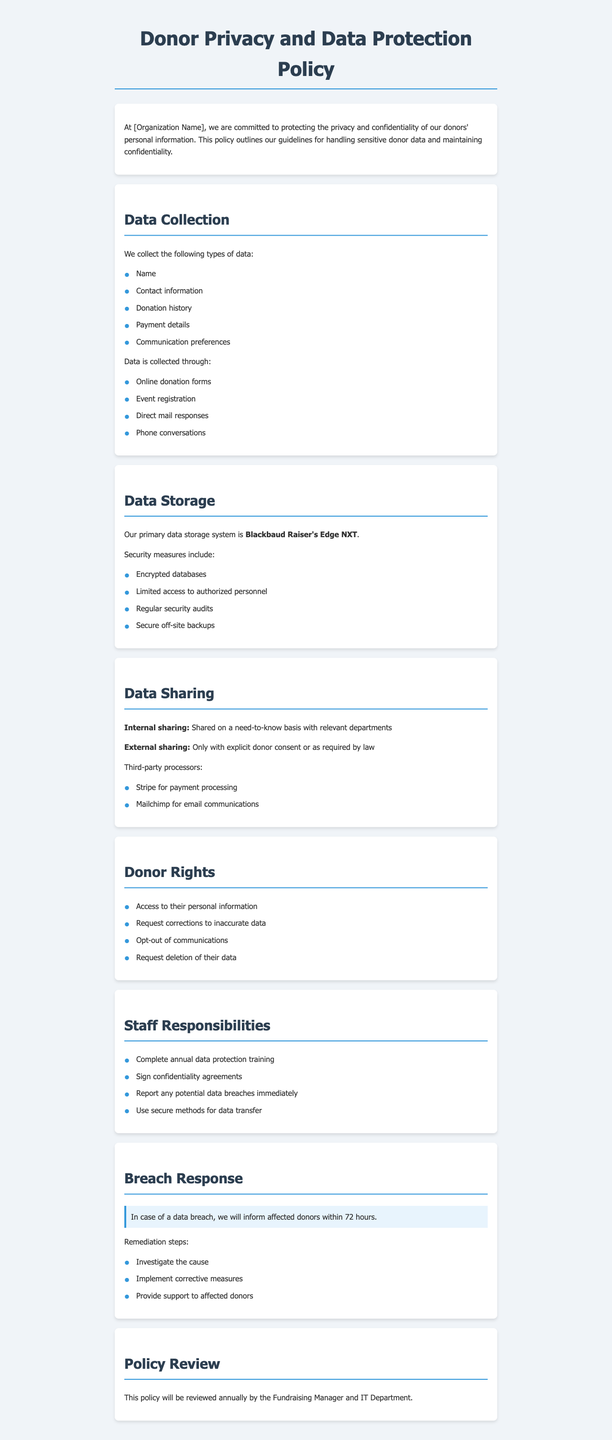What types of data are collected? The types of data collected are listed in the document under the "Data Collection" section.
Answer: Name, Contact information, Donation history, Payment details, Communication preferences What is the primary data storage system used? The primary data storage system is explicitly mentioned in the "Data Storage" section of the document.
Answer: Blackbaud Raiser's Edge NXT Who can access donor data? The document states access to donor data is limited to authorized personnel.
Answer: Authorized personnel What must staff do annually regarding data protection? This requirement for staff is outlined in the "Staff Responsibilities" section of the document.
Answer: Complete annual data protection training What should be done in case of a data breach? The steps are specified in the "Breach Response" section of the document regarding how to handle a data breach.
Answer: Inform affected donors within 72 hours What rights do donors have according to the policy? The rights of donors are enumerated in the "Donor Rights" section, indicating specific rights they possess.
Answer: Access to their personal information How often will the policy be reviewed? The frequency of the policy review is stated in the last section of the document.
Answer: Annually Which third-party processor is used for payment processing? The relevant third-party processor mentioned in the "Data Sharing" section of the document is specified.
Answer: Stripe 